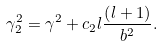<formula> <loc_0><loc_0><loc_500><loc_500>\gamma _ { 2 } ^ { 2 } = \gamma ^ { 2 } + c _ { 2 } l \frac { \left ( l + 1 \right ) } { b ^ { 2 } } .</formula> 